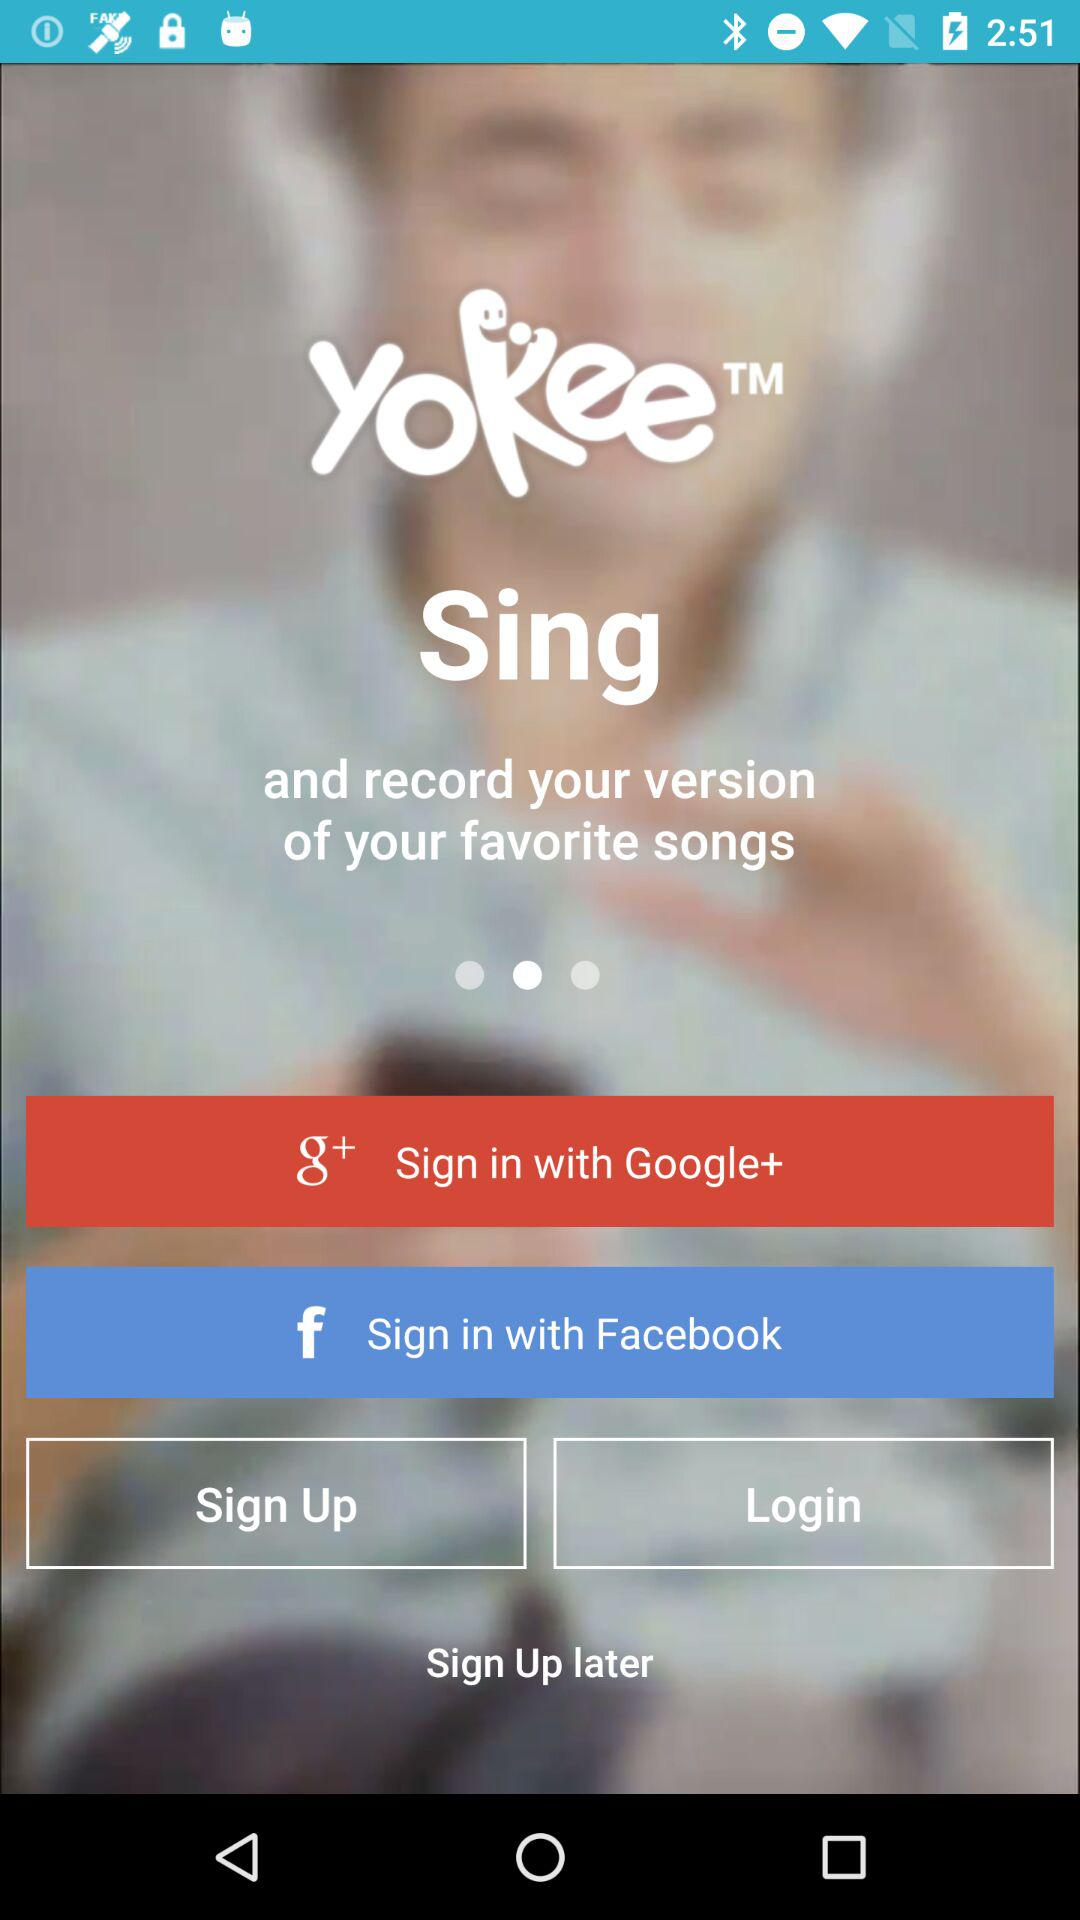What is the application name? The application name is "Yokee". 